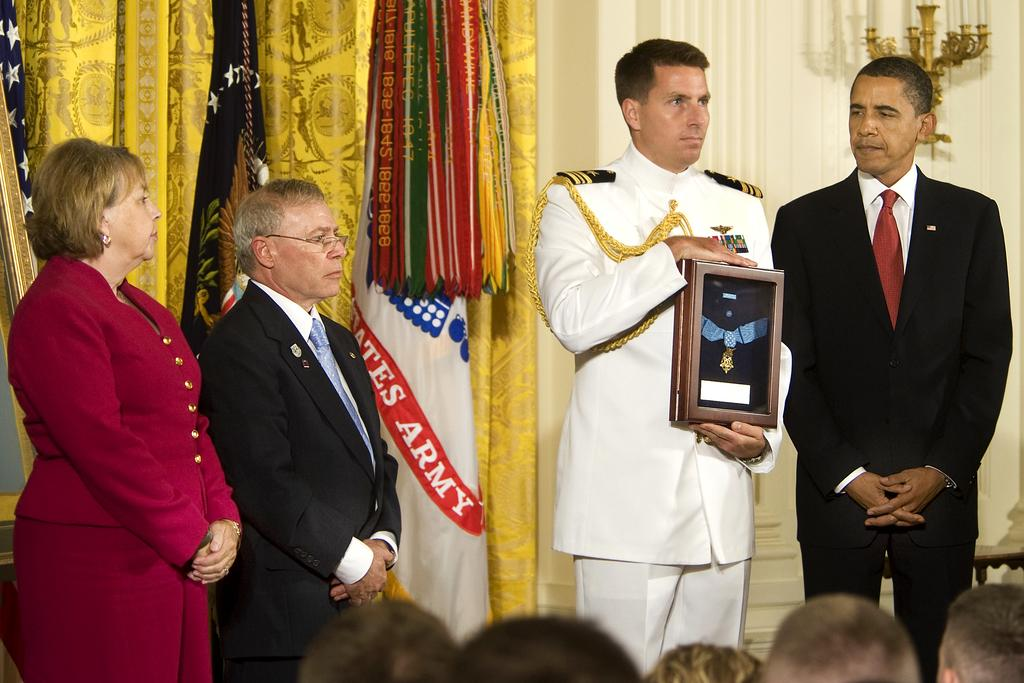<image>
Summarize the visual content of the image. a man in the army accepting a medal from the president 